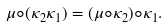Convert formula to latex. <formula><loc_0><loc_0><loc_500><loc_500>\mu \circ ( \kappa _ { 2 } \kappa _ { 1 } ) = ( \mu \circ \kappa _ { 2 } ) \circ \kappa _ { 1 } .</formula> 